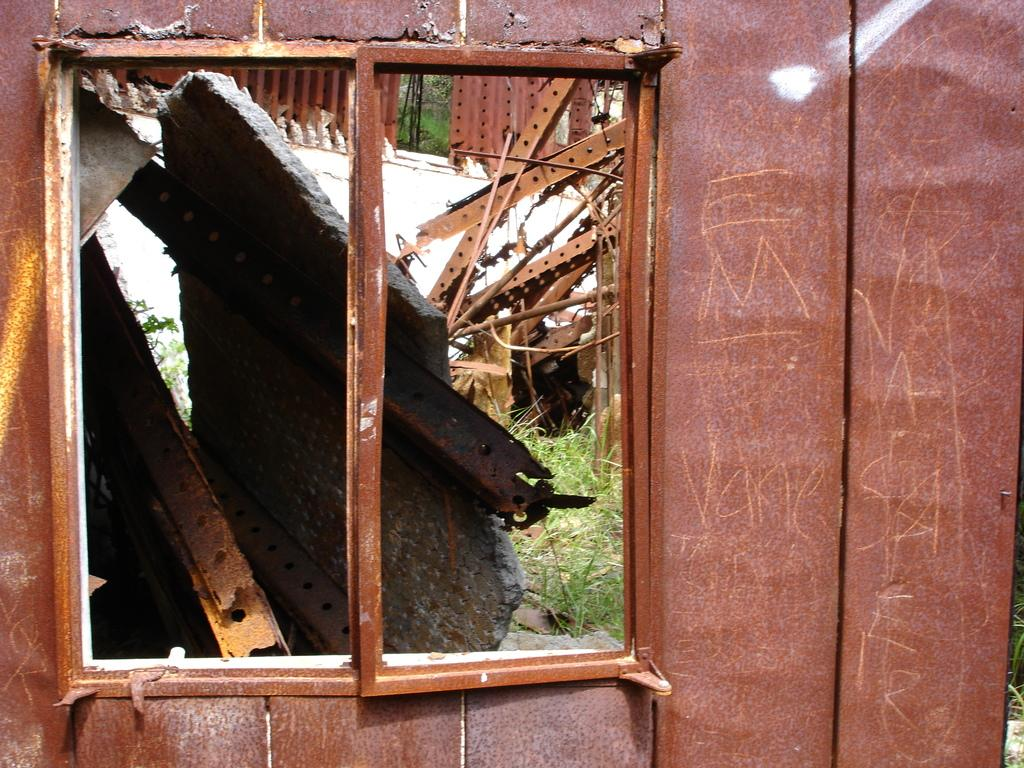What can be seen in the image that allows light to enter the building? There is a window in the image that allows light to enter the building. What is supporting the window in the image? Iron rods are present behind the window, supporting it. Where are the iron rods located in relation to the window? The iron rods are on the ground behind the window. What material is the building made of? The building is made of iron. What is the condition of the iron in the image? The iron is rusted. What religious symbol can be seen hanging from the window in the image? There is no religious symbol hanging from the window in the image; it only features a window, iron rods, and a rusted building. 